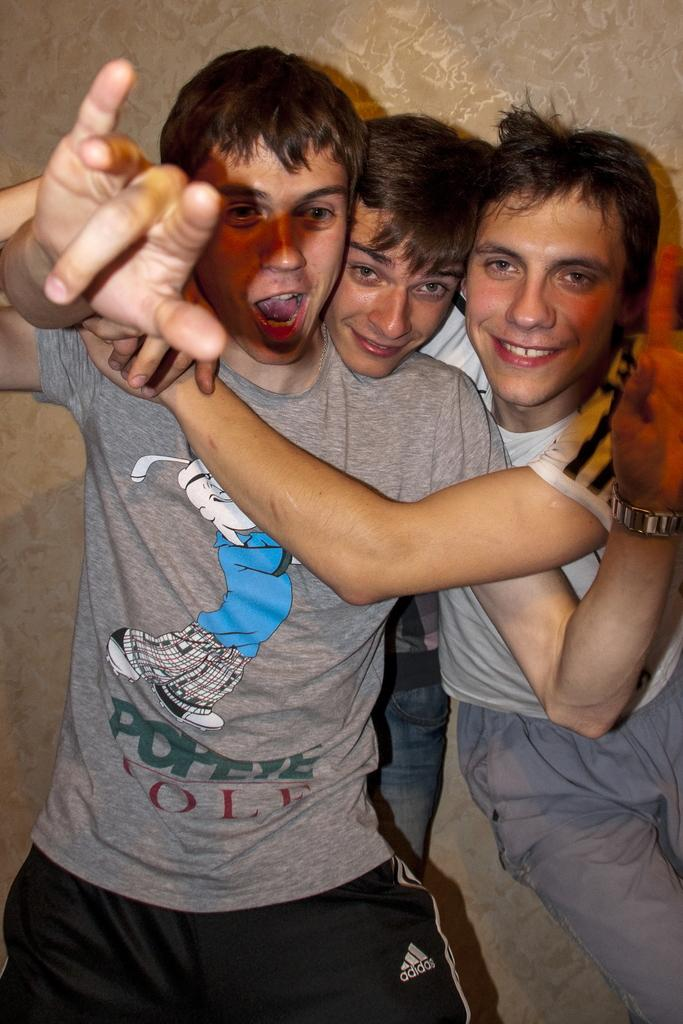<image>
Give a short and clear explanation of the subsequent image. A man wearing a Popeye shirt with two of his friends. 